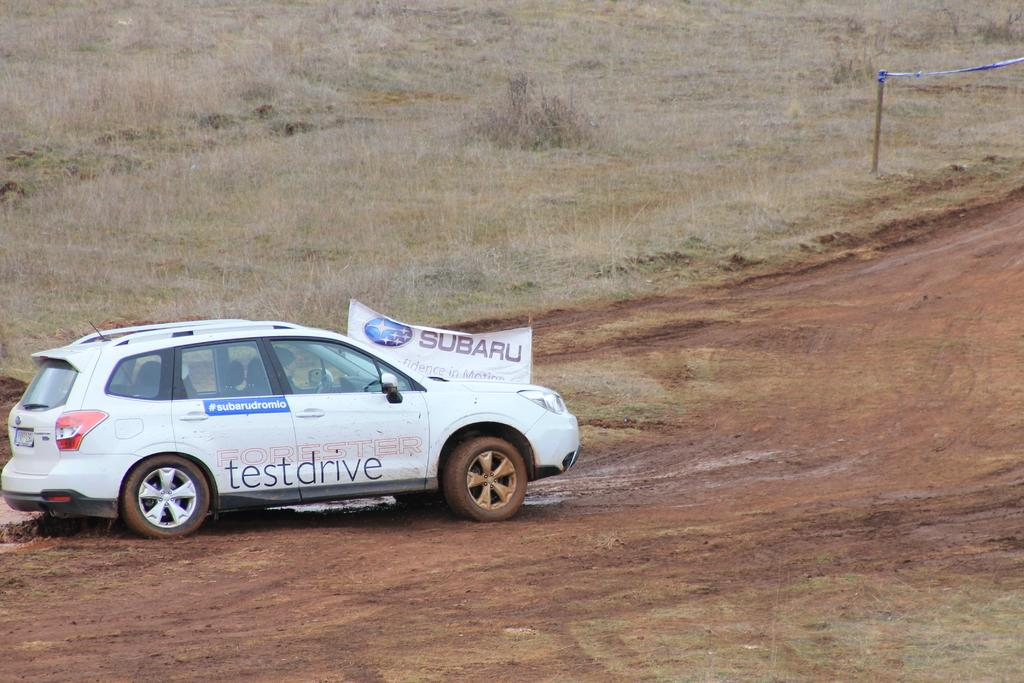What is the main object on the ground in the image? There is a vehicle on the ground in the image. What else can be seen in the image besides the vehicle? There is a banner and a pole with caution tape in the image. What type of surface is visible in the background of the image? The background of the image includes grass. What religious beliefs are represented by the things in the image? There is no indication of any religious beliefs in the image; it features a vehicle, a banner, a pole with caution tape, and grass in the background. 